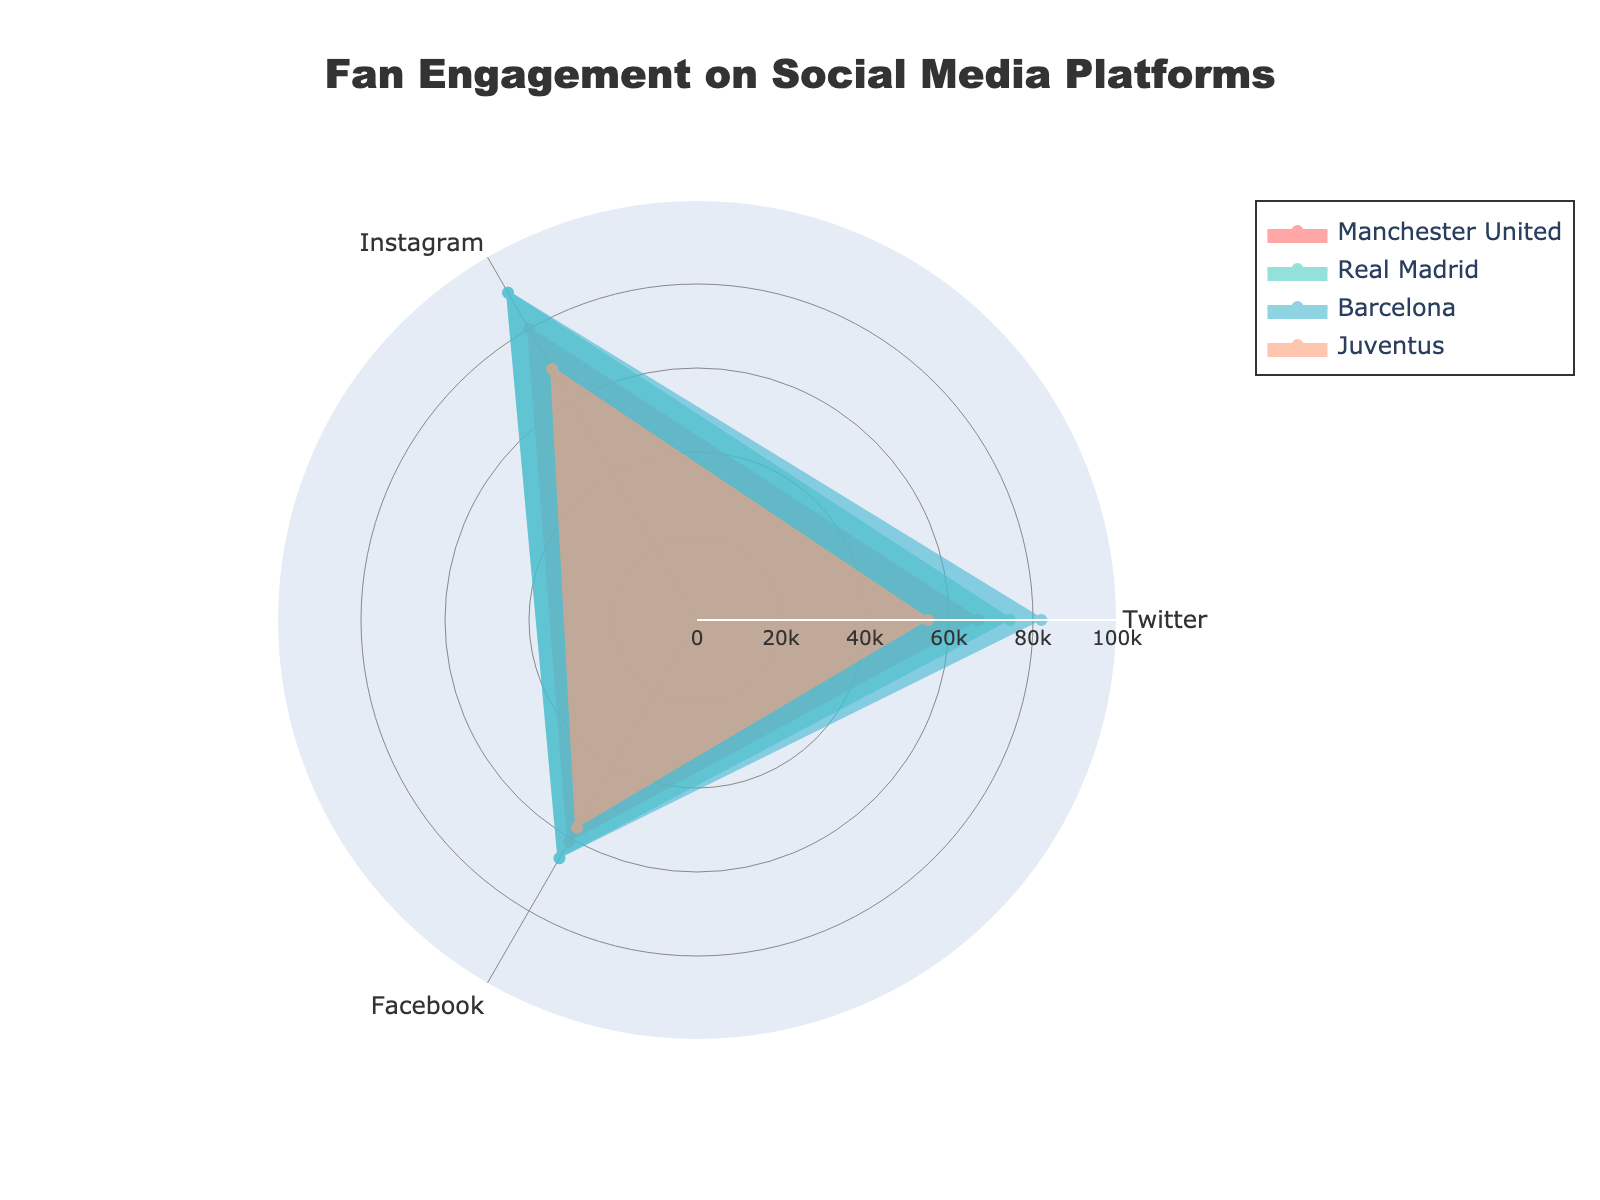What is the total fan engagement for Manchester United on Twitter? The total fan engagement for Manchester United on Twitter can be found by summing up their likes, shares, and comments. For Manchester United on Twitter, the values are 50000 likes, 7000 shares, and 10000 comments. Adding these together: 50000 + 7000 + 10000 = 67000.
Answer: 67000 Which club has the highest fan engagement on Instagram? To find the club with the highest fan engagement on Instagram, we compare the sum of likes, shares, and comments for each club on Instagram. The values for Instagram are:  
- Manchester United: 60000 + 8000 + 12000 = 80000  
- Real Madrid: 67000 + 9000 + 14000 = 90000  
- Barcelona: 65000 + 10000 + 15000 = 90000  
- Juventus: 52000 + 7000 + 10000 = 69000  
Both Real Madrid and Barcelona have the highest engagement at 90000 each.
Answer: Real Madrid and Barcelona Which platform does Juventus have the least fan engagement on? To determine the platform where Juventus has the least engagement, we sum up the fan engagement metrics for each platform: 
- Twitter: 40000 + 6000 + 9000 = 55000  
- Instagram: 52000 + 7000 + 10000 = 69000  
- Facebook: 43000 + 5600 + 8500 = 57100  
The platform with the least engagement is Twitter.
Answer: Twitter How does Real Madrid's total fan engagement on Facebook compare to that on Twitter? We first calculate the total fan engagement for Real Madrid on Facebook and Twitter:  
- Twitter: 55000 + 8500 + 11000 = 74500  
- Facebook: 47000 + 7500 + 11000 = 65500  
Real Madrid's total fan engagement on Twitter is 74500 and on Facebook is 65500. Twitter has higher engagement compared to Facebook.
Answer: Twitter has higher engagement What is the average fan engagement for Real Madrid on its social media platforms? Calculate the total fan engagement for Real Madrid on all platforms, then divide by the number of platforms:
- Total engagement: 74500 (Twitter) + 90000 (Instagram) + 65500 (Facebook) = 230000  
Average engagement = 230000 / 3 = 76666.67
Answer: 76666.67 